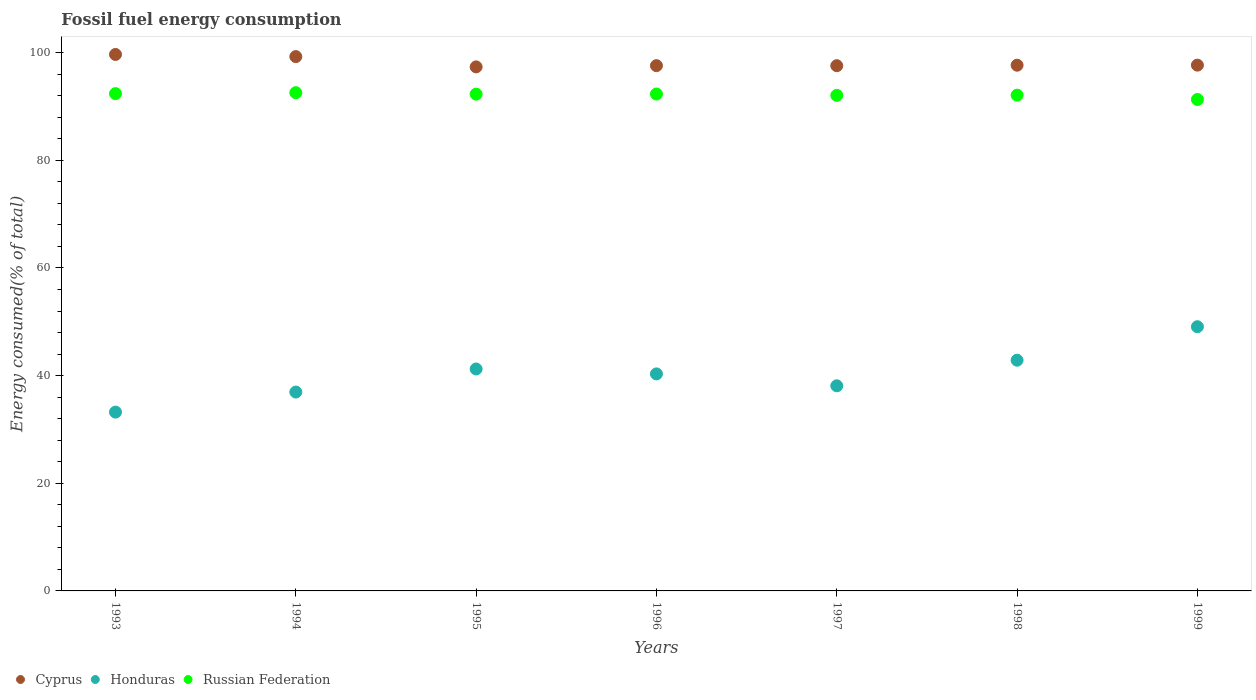Is the number of dotlines equal to the number of legend labels?
Offer a very short reply. Yes. What is the percentage of energy consumed in Honduras in 1994?
Give a very brief answer. 36.95. Across all years, what is the maximum percentage of energy consumed in Honduras?
Provide a short and direct response. 49.09. Across all years, what is the minimum percentage of energy consumed in Russian Federation?
Your answer should be compact. 91.31. In which year was the percentage of energy consumed in Russian Federation minimum?
Keep it short and to the point. 1999. What is the total percentage of energy consumed in Cyprus in the graph?
Offer a terse response. 686.87. What is the difference between the percentage of energy consumed in Cyprus in 1995 and that in 1998?
Provide a short and direct response. -0.31. What is the difference between the percentage of energy consumed in Cyprus in 1998 and the percentage of energy consumed in Honduras in 1996?
Your response must be concise. 57.35. What is the average percentage of energy consumed in Honduras per year?
Your response must be concise. 40.26. In the year 1993, what is the difference between the percentage of energy consumed in Honduras and percentage of energy consumed in Russian Federation?
Give a very brief answer. -59.17. What is the ratio of the percentage of energy consumed in Cyprus in 1994 to that in 1997?
Give a very brief answer. 1.02. Is the percentage of energy consumed in Honduras in 1996 less than that in 1998?
Your answer should be very brief. Yes. Is the difference between the percentage of energy consumed in Honduras in 1995 and 1997 greater than the difference between the percentage of energy consumed in Russian Federation in 1995 and 1997?
Offer a very short reply. Yes. What is the difference between the highest and the second highest percentage of energy consumed in Honduras?
Give a very brief answer. 6.22. What is the difference between the highest and the lowest percentage of energy consumed in Honduras?
Offer a very short reply. 15.87. Is the sum of the percentage of energy consumed in Cyprus in 1993 and 1995 greater than the maximum percentage of energy consumed in Russian Federation across all years?
Make the answer very short. Yes. Is it the case that in every year, the sum of the percentage of energy consumed in Cyprus and percentage of energy consumed in Honduras  is greater than the percentage of energy consumed in Russian Federation?
Your answer should be compact. Yes. Does the percentage of energy consumed in Cyprus monotonically increase over the years?
Make the answer very short. No. Is the percentage of energy consumed in Russian Federation strictly greater than the percentage of energy consumed in Honduras over the years?
Offer a very short reply. Yes. How many years are there in the graph?
Give a very brief answer. 7. What is the difference between two consecutive major ticks on the Y-axis?
Offer a terse response. 20. Does the graph contain grids?
Provide a short and direct response. No. Where does the legend appear in the graph?
Make the answer very short. Bottom left. How many legend labels are there?
Provide a succinct answer. 3. How are the legend labels stacked?
Your response must be concise. Horizontal. What is the title of the graph?
Make the answer very short. Fossil fuel energy consumption. What is the label or title of the X-axis?
Provide a succinct answer. Years. What is the label or title of the Y-axis?
Your answer should be very brief. Energy consumed(% of total). What is the Energy consumed(% of total) of Cyprus in 1993?
Give a very brief answer. 99.68. What is the Energy consumed(% of total) of Honduras in 1993?
Provide a short and direct response. 33.22. What is the Energy consumed(% of total) of Russian Federation in 1993?
Offer a terse response. 92.4. What is the Energy consumed(% of total) in Cyprus in 1994?
Provide a succinct answer. 99.28. What is the Energy consumed(% of total) in Honduras in 1994?
Your answer should be compact. 36.95. What is the Energy consumed(% of total) of Russian Federation in 1994?
Provide a succinct answer. 92.57. What is the Energy consumed(% of total) of Cyprus in 1995?
Keep it short and to the point. 97.37. What is the Energy consumed(% of total) in Honduras in 1995?
Make the answer very short. 41.24. What is the Energy consumed(% of total) in Russian Federation in 1995?
Keep it short and to the point. 92.3. What is the Energy consumed(% of total) in Cyprus in 1996?
Offer a very short reply. 97.59. What is the Energy consumed(% of total) of Honduras in 1996?
Provide a succinct answer. 40.32. What is the Energy consumed(% of total) of Russian Federation in 1996?
Make the answer very short. 92.32. What is the Energy consumed(% of total) of Cyprus in 1997?
Your answer should be compact. 97.59. What is the Energy consumed(% of total) in Honduras in 1997?
Offer a very short reply. 38.11. What is the Energy consumed(% of total) of Russian Federation in 1997?
Offer a very short reply. 92.07. What is the Energy consumed(% of total) of Cyprus in 1998?
Give a very brief answer. 97.68. What is the Energy consumed(% of total) in Honduras in 1998?
Offer a very short reply. 42.87. What is the Energy consumed(% of total) in Russian Federation in 1998?
Ensure brevity in your answer.  92.12. What is the Energy consumed(% of total) in Cyprus in 1999?
Provide a succinct answer. 97.69. What is the Energy consumed(% of total) in Honduras in 1999?
Your answer should be compact. 49.09. What is the Energy consumed(% of total) in Russian Federation in 1999?
Your answer should be compact. 91.31. Across all years, what is the maximum Energy consumed(% of total) of Cyprus?
Provide a succinct answer. 99.68. Across all years, what is the maximum Energy consumed(% of total) in Honduras?
Offer a terse response. 49.09. Across all years, what is the maximum Energy consumed(% of total) in Russian Federation?
Provide a succinct answer. 92.57. Across all years, what is the minimum Energy consumed(% of total) in Cyprus?
Make the answer very short. 97.37. Across all years, what is the minimum Energy consumed(% of total) in Honduras?
Provide a succinct answer. 33.22. Across all years, what is the minimum Energy consumed(% of total) in Russian Federation?
Your response must be concise. 91.31. What is the total Energy consumed(% of total) of Cyprus in the graph?
Give a very brief answer. 686.87. What is the total Energy consumed(% of total) of Honduras in the graph?
Give a very brief answer. 281.8. What is the total Energy consumed(% of total) of Russian Federation in the graph?
Your response must be concise. 645.09. What is the difference between the Energy consumed(% of total) of Cyprus in 1993 and that in 1994?
Your answer should be compact. 0.4. What is the difference between the Energy consumed(% of total) in Honduras in 1993 and that in 1994?
Provide a short and direct response. -3.73. What is the difference between the Energy consumed(% of total) of Russian Federation in 1993 and that in 1994?
Your response must be concise. -0.18. What is the difference between the Energy consumed(% of total) in Cyprus in 1993 and that in 1995?
Make the answer very short. 2.31. What is the difference between the Energy consumed(% of total) in Honduras in 1993 and that in 1995?
Offer a terse response. -8.01. What is the difference between the Energy consumed(% of total) in Russian Federation in 1993 and that in 1995?
Keep it short and to the point. 0.09. What is the difference between the Energy consumed(% of total) in Cyprus in 1993 and that in 1996?
Provide a succinct answer. 2.08. What is the difference between the Energy consumed(% of total) of Honduras in 1993 and that in 1996?
Keep it short and to the point. -7.1. What is the difference between the Energy consumed(% of total) of Russian Federation in 1993 and that in 1996?
Ensure brevity in your answer.  0.07. What is the difference between the Energy consumed(% of total) in Cyprus in 1993 and that in 1997?
Your response must be concise. 2.09. What is the difference between the Energy consumed(% of total) in Honduras in 1993 and that in 1997?
Keep it short and to the point. -4.89. What is the difference between the Energy consumed(% of total) in Russian Federation in 1993 and that in 1997?
Your answer should be very brief. 0.32. What is the difference between the Energy consumed(% of total) of Cyprus in 1993 and that in 1998?
Give a very brief answer. 2. What is the difference between the Energy consumed(% of total) in Honduras in 1993 and that in 1998?
Your answer should be very brief. -9.64. What is the difference between the Energy consumed(% of total) of Russian Federation in 1993 and that in 1998?
Give a very brief answer. 0.28. What is the difference between the Energy consumed(% of total) in Cyprus in 1993 and that in 1999?
Provide a succinct answer. 1.98. What is the difference between the Energy consumed(% of total) in Honduras in 1993 and that in 1999?
Make the answer very short. -15.87. What is the difference between the Energy consumed(% of total) in Russian Federation in 1993 and that in 1999?
Keep it short and to the point. 1.09. What is the difference between the Energy consumed(% of total) of Cyprus in 1994 and that in 1995?
Offer a very short reply. 1.91. What is the difference between the Energy consumed(% of total) in Honduras in 1994 and that in 1995?
Give a very brief answer. -4.28. What is the difference between the Energy consumed(% of total) of Russian Federation in 1994 and that in 1995?
Give a very brief answer. 0.27. What is the difference between the Energy consumed(% of total) in Cyprus in 1994 and that in 1996?
Your answer should be compact. 1.68. What is the difference between the Energy consumed(% of total) in Honduras in 1994 and that in 1996?
Your response must be concise. -3.37. What is the difference between the Energy consumed(% of total) of Russian Federation in 1994 and that in 1996?
Provide a succinct answer. 0.25. What is the difference between the Energy consumed(% of total) in Cyprus in 1994 and that in 1997?
Ensure brevity in your answer.  1.69. What is the difference between the Energy consumed(% of total) in Honduras in 1994 and that in 1997?
Make the answer very short. -1.16. What is the difference between the Energy consumed(% of total) of Russian Federation in 1994 and that in 1997?
Make the answer very short. 0.5. What is the difference between the Energy consumed(% of total) in Cyprus in 1994 and that in 1998?
Provide a succinct answer. 1.6. What is the difference between the Energy consumed(% of total) of Honduras in 1994 and that in 1998?
Your answer should be compact. -5.92. What is the difference between the Energy consumed(% of total) in Russian Federation in 1994 and that in 1998?
Keep it short and to the point. 0.46. What is the difference between the Energy consumed(% of total) in Cyprus in 1994 and that in 1999?
Ensure brevity in your answer.  1.59. What is the difference between the Energy consumed(% of total) of Honduras in 1994 and that in 1999?
Offer a terse response. -12.14. What is the difference between the Energy consumed(% of total) of Russian Federation in 1994 and that in 1999?
Keep it short and to the point. 1.26. What is the difference between the Energy consumed(% of total) of Cyprus in 1995 and that in 1996?
Your answer should be compact. -0.23. What is the difference between the Energy consumed(% of total) of Honduras in 1995 and that in 1996?
Your response must be concise. 0.91. What is the difference between the Energy consumed(% of total) of Russian Federation in 1995 and that in 1996?
Your response must be concise. -0.02. What is the difference between the Energy consumed(% of total) in Cyprus in 1995 and that in 1997?
Give a very brief answer. -0.22. What is the difference between the Energy consumed(% of total) in Honduras in 1995 and that in 1997?
Provide a succinct answer. 3.13. What is the difference between the Energy consumed(% of total) in Russian Federation in 1995 and that in 1997?
Make the answer very short. 0.23. What is the difference between the Energy consumed(% of total) in Cyprus in 1995 and that in 1998?
Offer a terse response. -0.31. What is the difference between the Energy consumed(% of total) of Honduras in 1995 and that in 1998?
Your answer should be compact. -1.63. What is the difference between the Energy consumed(% of total) in Russian Federation in 1995 and that in 1998?
Provide a succinct answer. 0.19. What is the difference between the Energy consumed(% of total) of Cyprus in 1995 and that in 1999?
Offer a very short reply. -0.33. What is the difference between the Energy consumed(% of total) in Honduras in 1995 and that in 1999?
Keep it short and to the point. -7.85. What is the difference between the Energy consumed(% of total) of Cyprus in 1996 and that in 1997?
Ensure brevity in your answer.  0.01. What is the difference between the Energy consumed(% of total) in Honduras in 1996 and that in 1997?
Make the answer very short. 2.21. What is the difference between the Energy consumed(% of total) of Russian Federation in 1996 and that in 1997?
Your answer should be very brief. 0.25. What is the difference between the Energy consumed(% of total) in Cyprus in 1996 and that in 1998?
Give a very brief answer. -0.08. What is the difference between the Energy consumed(% of total) of Honduras in 1996 and that in 1998?
Your answer should be compact. -2.55. What is the difference between the Energy consumed(% of total) of Russian Federation in 1996 and that in 1998?
Your answer should be compact. 0.21. What is the difference between the Energy consumed(% of total) of Cyprus in 1996 and that in 1999?
Keep it short and to the point. -0.1. What is the difference between the Energy consumed(% of total) of Honduras in 1996 and that in 1999?
Your response must be concise. -8.77. What is the difference between the Energy consumed(% of total) in Russian Federation in 1996 and that in 1999?
Offer a terse response. 1.01. What is the difference between the Energy consumed(% of total) of Cyprus in 1997 and that in 1998?
Your answer should be compact. -0.09. What is the difference between the Energy consumed(% of total) in Honduras in 1997 and that in 1998?
Keep it short and to the point. -4.76. What is the difference between the Energy consumed(% of total) of Russian Federation in 1997 and that in 1998?
Your answer should be very brief. -0.04. What is the difference between the Energy consumed(% of total) in Cyprus in 1997 and that in 1999?
Give a very brief answer. -0.11. What is the difference between the Energy consumed(% of total) of Honduras in 1997 and that in 1999?
Your response must be concise. -10.98. What is the difference between the Energy consumed(% of total) of Russian Federation in 1997 and that in 1999?
Give a very brief answer. 0.76. What is the difference between the Energy consumed(% of total) in Cyprus in 1998 and that in 1999?
Keep it short and to the point. -0.01. What is the difference between the Energy consumed(% of total) of Honduras in 1998 and that in 1999?
Ensure brevity in your answer.  -6.22. What is the difference between the Energy consumed(% of total) in Russian Federation in 1998 and that in 1999?
Make the answer very short. 0.81. What is the difference between the Energy consumed(% of total) in Cyprus in 1993 and the Energy consumed(% of total) in Honduras in 1994?
Make the answer very short. 62.72. What is the difference between the Energy consumed(% of total) in Cyprus in 1993 and the Energy consumed(% of total) in Russian Federation in 1994?
Make the answer very short. 7.1. What is the difference between the Energy consumed(% of total) in Honduras in 1993 and the Energy consumed(% of total) in Russian Federation in 1994?
Make the answer very short. -59.35. What is the difference between the Energy consumed(% of total) in Cyprus in 1993 and the Energy consumed(% of total) in Honduras in 1995?
Provide a short and direct response. 58.44. What is the difference between the Energy consumed(% of total) of Cyprus in 1993 and the Energy consumed(% of total) of Russian Federation in 1995?
Your answer should be compact. 7.37. What is the difference between the Energy consumed(% of total) of Honduras in 1993 and the Energy consumed(% of total) of Russian Federation in 1995?
Your answer should be very brief. -59.08. What is the difference between the Energy consumed(% of total) of Cyprus in 1993 and the Energy consumed(% of total) of Honduras in 1996?
Offer a terse response. 59.35. What is the difference between the Energy consumed(% of total) in Cyprus in 1993 and the Energy consumed(% of total) in Russian Federation in 1996?
Make the answer very short. 7.35. What is the difference between the Energy consumed(% of total) in Honduras in 1993 and the Energy consumed(% of total) in Russian Federation in 1996?
Your response must be concise. -59.1. What is the difference between the Energy consumed(% of total) of Cyprus in 1993 and the Energy consumed(% of total) of Honduras in 1997?
Provide a short and direct response. 61.57. What is the difference between the Energy consumed(% of total) of Cyprus in 1993 and the Energy consumed(% of total) of Russian Federation in 1997?
Offer a very short reply. 7.6. What is the difference between the Energy consumed(% of total) of Honduras in 1993 and the Energy consumed(% of total) of Russian Federation in 1997?
Give a very brief answer. -58.85. What is the difference between the Energy consumed(% of total) of Cyprus in 1993 and the Energy consumed(% of total) of Honduras in 1998?
Keep it short and to the point. 56.81. What is the difference between the Energy consumed(% of total) of Cyprus in 1993 and the Energy consumed(% of total) of Russian Federation in 1998?
Your answer should be compact. 7.56. What is the difference between the Energy consumed(% of total) in Honduras in 1993 and the Energy consumed(% of total) in Russian Federation in 1998?
Ensure brevity in your answer.  -58.89. What is the difference between the Energy consumed(% of total) in Cyprus in 1993 and the Energy consumed(% of total) in Honduras in 1999?
Give a very brief answer. 50.59. What is the difference between the Energy consumed(% of total) in Cyprus in 1993 and the Energy consumed(% of total) in Russian Federation in 1999?
Your answer should be very brief. 8.37. What is the difference between the Energy consumed(% of total) in Honduras in 1993 and the Energy consumed(% of total) in Russian Federation in 1999?
Keep it short and to the point. -58.09. What is the difference between the Energy consumed(% of total) of Cyprus in 1994 and the Energy consumed(% of total) of Honduras in 1995?
Provide a succinct answer. 58.04. What is the difference between the Energy consumed(% of total) of Cyprus in 1994 and the Energy consumed(% of total) of Russian Federation in 1995?
Provide a short and direct response. 6.98. What is the difference between the Energy consumed(% of total) of Honduras in 1994 and the Energy consumed(% of total) of Russian Federation in 1995?
Provide a succinct answer. -55.35. What is the difference between the Energy consumed(% of total) of Cyprus in 1994 and the Energy consumed(% of total) of Honduras in 1996?
Offer a terse response. 58.95. What is the difference between the Energy consumed(% of total) of Cyprus in 1994 and the Energy consumed(% of total) of Russian Federation in 1996?
Your response must be concise. 6.95. What is the difference between the Energy consumed(% of total) in Honduras in 1994 and the Energy consumed(% of total) in Russian Federation in 1996?
Ensure brevity in your answer.  -55.37. What is the difference between the Energy consumed(% of total) in Cyprus in 1994 and the Energy consumed(% of total) in Honduras in 1997?
Provide a succinct answer. 61.17. What is the difference between the Energy consumed(% of total) in Cyprus in 1994 and the Energy consumed(% of total) in Russian Federation in 1997?
Make the answer very short. 7.21. What is the difference between the Energy consumed(% of total) of Honduras in 1994 and the Energy consumed(% of total) of Russian Federation in 1997?
Offer a terse response. -55.12. What is the difference between the Energy consumed(% of total) of Cyprus in 1994 and the Energy consumed(% of total) of Honduras in 1998?
Your answer should be compact. 56.41. What is the difference between the Energy consumed(% of total) in Cyprus in 1994 and the Energy consumed(% of total) in Russian Federation in 1998?
Make the answer very short. 7.16. What is the difference between the Energy consumed(% of total) in Honduras in 1994 and the Energy consumed(% of total) in Russian Federation in 1998?
Provide a succinct answer. -55.16. What is the difference between the Energy consumed(% of total) in Cyprus in 1994 and the Energy consumed(% of total) in Honduras in 1999?
Your response must be concise. 50.19. What is the difference between the Energy consumed(% of total) of Cyprus in 1994 and the Energy consumed(% of total) of Russian Federation in 1999?
Your response must be concise. 7.97. What is the difference between the Energy consumed(% of total) in Honduras in 1994 and the Energy consumed(% of total) in Russian Federation in 1999?
Provide a short and direct response. -54.36. What is the difference between the Energy consumed(% of total) of Cyprus in 1995 and the Energy consumed(% of total) of Honduras in 1996?
Your answer should be compact. 57.04. What is the difference between the Energy consumed(% of total) of Cyprus in 1995 and the Energy consumed(% of total) of Russian Federation in 1996?
Make the answer very short. 5.04. What is the difference between the Energy consumed(% of total) of Honduras in 1995 and the Energy consumed(% of total) of Russian Federation in 1996?
Make the answer very short. -51.09. What is the difference between the Energy consumed(% of total) in Cyprus in 1995 and the Energy consumed(% of total) in Honduras in 1997?
Provide a short and direct response. 59.26. What is the difference between the Energy consumed(% of total) of Cyprus in 1995 and the Energy consumed(% of total) of Russian Federation in 1997?
Your answer should be compact. 5.29. What is the difference between the Energy consumed(% of total) of Honduras in 1995 and the Energy consumed(% of total) of Russian Federation in 1997?
Your answer should be compact. -50.84. What is the difference between the Energy consumed(% of total) of Cyprus in 1995 and the Energy consumed(% of total) of Honduras in 1998?
Offer a very short reply. 54.5. What is the difference between the Energy consumed(% of total) of Cyprus in 1995 and the Energy consumed(% of total) of Russian Federation in 1998?
Provide a succinct answer. 5.25. What is the difference between the Energy consumed(% of total) of Honduras in 1995 and the Energy consumed(% of total) of Russian Federation in 1998?
Provide a short and direct response. -50.88. What is the difference between the Energy consumed(% of total) of Cyprus in 1995 and the Energy consumed(% of total) of Honduras in 1999?
Your answer should be very brief. 48.28. What is the difference between the Energy consumed(% of total) in Cyprus in 1995 and the Energy consumed(% of total) in Russian Federation in 1999?
Keep it short and to the point. 6.06. What is the difference between the Energy consumed(% of total) of Honduras in 1995 and the Energy consumed(% of total) of Russian Federation in 1999?
Keep it short and to the point. -50.07. What is the difference between the Energy consumed(% of total) in Cyprus in 1996 and the Energy consumed(% of total) in Honduras in 1997?
Your answer should be compact. 59.48. What is the difference between the Energy consumed(% of total) of Cyprus in 1996 and the Energy consumed(% of total) of Russian Federation in 1997?
Your answer should be very brief. 5.52. What is the difference between the Energy consumed(% of total) in Honduras in 1996 and the Energy consumed(% of total) in Russian Federation in 1997?
Provide a short and direct response. -51.75. What is the difference between the Energy consumed(% of total) of Cyprus in 1996 and the Energy consumed(% of total) of Honduras in 1998?
Provide a succinct answer. 54.72. What is the difference between the Energy consumed(% of total) in Cyprus in 1996 and the Energy consumed(% of total) in Russian Federation in 1998?
Make the answer very short. 5.48. What is the difference between the Energy consumed(% of total) in Honduras in 1996 and the Energy consumed(% of total) in Russian Federation in 1998?
Offer a terse response. -51.79. What is the difference between the Energy consumed(% of total) in Cyprus in 1996 and the Energy consumed(% of total) in Honduras in 1999?
Your answer should be compact. 48.5. What is the difference between the Energy consumed(% of total) in Cyprus in 1996 and the Energy consumed(% of total) in Russian Federation in 1999?
Your answer should be very brief. 6.28. What is the difference between the Energy consumed(% of total) in Honduras in 1996 and the Energy consumed(% of total) in Russian Federation in 1999?
Give a very brief answer. -50.99. What is the difference between the Energy consumed(% of total) of Cyprus in 1997 and the Energy consumed(% of total) of Honduras in 1998?
Your answer should be very brief. 54.72. What is the difference between the Energy consumed(% of total) of Cyprus in 1997 and the Energy consumed(% of total) of Russian Federation in 1998?
Give a very brief answer. 5.47. What is the difference between the Energy consumed(% of total) in Honduras in 1997 and the Energy consumed(% of total) in Russian Federation in 1998?
Make the answer very short. -54.01. What is the difference between the Energy consumed(% of total) in Cyprus in 1997 and the Energy consumed(% of total) in Honduras in 1999?
Offer a very short reply. 48.5. What is the difference between the Energy consumed(% of total) of Cyprus in 1997 and the Energy consumed(% of total) of Russian Federation in 1999?
Offer a very short reply. 6.28. What is the difference between the Energy consumed(% of total) of Honduras in 1997 and the Energy consumed(% of total) of Russian Federation in 1999?
Offer a very short reply. -53.2. What is the difference between the Energy consumed(% of total) in Cyprus in 1998 and the Energy consumed(% of total) in Honduras in 1999?
Give a very brief answer. 48.59. What is the difference between the Energy consumed(% of total) of Cyprus in 1998 and the Energy consumed(% of total) of Russian Federation in 1999?
Ensure brevity in your answer.  6.37. What is the difference between the Energy consumed(% of total) in Honduras in 1998 and the Energy consumed(% of total) in Russian Federation in 1999?
Your response must be concise. -48.44. What is the average Energy consumed(% of total) in Cyprus per year?
Ensure brevity in your answer.  98.12. What is the average Energy consumed(% of total) of Honduras per year?
Keep it short and to the point. 40.26. What is the average Energy consumed(% of total) in Russian Federation per year?
Your answer should be very brief. 92.16. In the year 1993, what is the difference between the Energy consumed(% of total) of Cyprus and Energy consumed(% of total) of Honduras?
Your response must be concise. 66.45. In the year 1993, what is the difference between the Energy consumed(% of total) in Cyprus and Energy consumed(% of total) in Russian Federation?
Your answer should be compact. 7.28. In the year 1993, what is the difference between the Energy consumed(% of total) in Honduras and Energy consumed(% of total) in Russian Federation?
Your response must be concise. -59.17. In the year 1994, what is the difference between the Energy consumed(% of total) of Cyprus and Energy consumed(% of total) of Honduras?
Make the answer very short. 62.33. In the year 1994, what is the difference between the Energy consumed(% of total) in Cyprus and Energy consumed(% of total) in Russian Federation?
Provide a succinct answer. 6.7. In the year 1994, what is the difference between the Energy consumed(% of total) in Honduras and Energy consumed(% of total) in Russian Federation?
Offer a terse response. -55.62. In the year 1995, what is the difference between the Energy consumed(% of total) in Cyprus and Energy consumed(% of total) in Honduras?
Keep it short and to the point. 56.13. In the year 1995, what is the difference between the Energy consumed(% of total) in Cyprus and Energy consumed(% of total) in Russian Federation?
Your answer should be compact. 5.06. In the year 1995, what is the difference between the Energy consumed(% of total) of Honduras and Energy consumed(% of total) of Russian Federation?
Give a very brief answer. -51.06. In the year 1996, what is the difference between the Energy consumed(% of total) in Cyprus and Energy consumed(% of total) in Honduras?
Provide a succinct answer. 57.27. In the year 1996, what is the difference between the Energy consumed(% of total) of Cyprus and Energy consumed(% of total) of Russian Federation?
Offer a very short reply. 5.27. In the year 1996, what is the difference between the Energy consumed(% of total) of Honduras and Energy consumed(% of total) of Russian Federation?
Offer a terse response. -52. In the year 1997, what is the difference between the Energy consumed(% of total) of Cyprus and Energy consumed(% of total) of Honduras?
Your answer should be compact. 59.48. In the year 1997, what is the difference between the Energy consumed(% of total) of Cyprus and Energy consumed(% of total) of Russian Federation?
Your response must be concise. 5.51. In the year 1997, what is the difference between the Energy consumed(% of total) in Honduras and Energy consumed(% of total) in Russian Federation?
Give a very brief answer. -53.96. In the year 1998, what is the difference between the Energy consumed(% of total) in Cyprus and Energy consumed(% of total) in Honduras?
Your answer should be very brief. 54.81. In the year 1998, what is the difference between the Energy consumed(% of total) of Cyprus and Energy consumed(% of total) of Russian Federation?
Your answer should be very brief. 5.56. In the year 1998, what is the difference between the Energy consumed(% of total) in Honduras and Energy consumed(% of total) in Russian Federation?
Your response must be concise. -49.25. In the year 1999, what is the difference between the Energy consumed(% of total) in Cyprus and Energy consumed(% of total) in Honduras?
Make the answer very short. 48.6. In the year 1999, what is the difference between the Energy consumed(% of total) of Cyprus and Energy consumed(% of total) of Russian Federation?
Make the answer very short. 6.38. In the year 1999, what is the difference between the Energy consumed(% of total) in Honduras and Energy consumed(% of total) in Russian Federation?
Ensure brevity in your answer.  -42.22. What is the ratio of the Energy consumed(% of total) of Honduras in 1993 to that in 1994?
Your answer should be compact. 0.9. What is the ratio of the Energy consumed(% of total) in Russian Federation in 1993 to that in 1994?
Give a very brief answer. 1. What is the ratio of the Energy consumed(% of total) of Cyprus in 1993 to that in 1995?
Offer a very short reply. 1.02. What is the ratio of the Energy consumed(% of total) in Honduras in 1993 to that in 1995?
Provide a succinct answer. 0.81. What is the ratio of the Energy consumed(% of total) in Russian Federation in 1993 to that in 1995?
Your answer should be very brief. 1. What is the ratio of the Energy consumed(% of total) in Cyprus in 1993 to that in 1996?
Your answer should be compact. 1.02. What is the ratio of the Energy consumed(% of total) in Honduras in 1993 to that in 1996?
Give a very brief answer. 0.82. What is the ratio of the Energy consumed(% of total) in Russian Federation in 1993 to that in 1996?
Keep it short and to the point. 1. What is the ratio of the Energy consumed(% of total) of Cyprus in 1993 to that in 1997?
Your response must be concise. 1.02. What is the ratio of the Energy consumed(% of total) of Honduras in 1993 to that in 1997?
Your answer should be compact. 0.87. What is the ratio of the Energy consumed(% of total) in Russian Federation in 1993 to that in 1997?
Give a very brief answer. 1. What is the ratio of the Energy consumed(% of total) of Cyprus in 1993 to that in 1998?
Offer a very short reply. 1.02. What is the ratio of the Energy consumed(% of total) of Honduras in 1993 to that in 1998?
Your answer should be compact. 0.78. What is the ratio of the Energy consumed(% of total) in Cyprus in 1993 to that in 1999?
Offer a very short reply. 1.02. What is the ratio of the Energy consumed(% of total) of Honduras in 1993 to that in 1999?
Provide a succinct answer. 0.68. What is the ratio of the Energy consumed(% of total) in Russian Federation in 1993 to that in 1999?
Provide a succinct answer. 1.01. What is the ratio of the Energy consumed(% of total) in Cyprus in 1994 to that in 1995?
Give a very brief answer. 1.02. What is the ratio of the Energy consumed(% of total) of Honduras in 1994 to that in 1995?
Ensure brevity in your answer.  0.9. What is the ratio of the Energy consumed(% of total) of Russian Federation in 1994 to that in 1995?
Provide a short and direct response. 1. What is the ratio of the Energy consumed(% of total) of Cyprus in 1994 to that in 1996?
Make the answer very short. 1.02. What is the ratio of the Energy consumed(% of total) of Honduras in 1994 to that in 1996?
Offer a very short reply. 0.92. What is the ratio of the Energy consumed(% of total) of Russian Federation in 1994 to that in 1996?
Provide a short and direct response. 1. What is the ratio of the Energy consumed(% of total) of Cyprus in 1994 to that in 1997?
Your response must be concise. 1.02. What is the ratio of the Energy consumed(% of total) of Honduras in 1994 to that in 1997?
Provide a short and direct response. 0.97. What is the ratio of the Energy consumed(% of total) in Russian Federation in 1994 to that in 1997?
Make the answer very short. 1.01. What is the ratio of the Energy consumed(% of total) of Cyprus in 1994 to that in 1998?
Your answer should be very brief. 1.02. What is the ratio of the Energy consumed(% of total) in Honduras in 1994 to that in 1998?
Offer a terse response. 0.86. What is the ratio of the Energy consumed(% of total) of Russian Federation in 1994 to that in 1998?
Offer a very short reply. 1. What is the ratio of the Energy consumed(% of total) of Cyprus in 1994 to that in 1999?
Provide a succinct answer. 1.02. What is the ratio of the Energy consumed(% of total) of Honduras in 1994 to that in 1999?
Provide a succinct answer. 0.75. What is the ratio of the Energy consumed(% of total) in Russian Federation in 1994 to that in 1999?
Offer a terse response. 1.01. What is the ratio of the Energy consumed(% of total) of Honduras in 1995 to that in 1996?
Keep it short and to the point. 1.02. What is the ratio of the Energy consumed(% of total) in Russian Federation in 1995 to that in 1996?
Ensure brevity in your answer.  1. What is the ratio of the Energy consumed(% of total) of Cyprus in 1995 to that in 1997?
Offer a terse response. 1. What is the ratio of the Energy consumed(% of total) in Honduras in 1995 to that in 1997?
Offer a very short reply. 1.08. What is the ratio of the Energy consumed(% of total) in Russian Federation in 1995 to that in 1997?
Provide a succinct answer. 1. What is the ratio of the Energy consumed(% of total) in Honduras in 1995 to that in 1998?
Make the answer very short. 0.96. What is the ratio of the Energy consumed(% of total) of Russian Federation in 1995 to that in 1998?
Keep it short and to the point. 1. What is the ratio of the Energy consumed(% of total) of Honduras in 1995 to that in 1999?
Ensure brevity in your answer.  0.84. What is the ratio of the Energy consumed(% of total) in Russian Federation in 1995 to that in 1999?
Offer a very short reply. 1.01. What is the ratio of the Energy consumed(% of total) of Honduras in 1996 to that in 1997?
Your answer should be compact. 1.06. What is the ratio of the Energy consumed(% of total) of Russian Federation in 1996 to that in 1997?
Your response must be concise. 1. What is the ratio of the Energy consumed(% of total) in Cyprus in 1996 to that in 1998?
Make the answer very short. 1. What is the ratio of the Energy consumed(% of total) of Honduras in 1996 to that in 1998?
Give a very brief answer. 0.94. What is the ratio of the Energy consumed(% of total) in Russian Federation in 1996 to that in 1998?
Your answer should be very brief. 1. What is the ratio of the Energy consumed(% of total) in Cyprus in 1996 to that in 1999?
Keep it short and to the point. 1. What is the ratio of the Energy consumed(% of total) of Honduras in 1996 to that in 1999?
Offer a terse response. 0.82. What is the ratio of the Energy consumed(% of total) in Russian Federation in 1996 to that in 1999?
Give a very brief answer. 1.01. What is the ratio of the Energy consumed(% of total) in Honduras in 1997 to that in 1998?
Give a very brief answer. 0.89. What is the ratio of the Energy consumed(% of total) in Cyprus in 1997 to that in 1999?
Ensure brevity in your answer.  1. What is the ratio of the Energy consumed(% of total) of Honduras in 1997 to that in 1999?
Your answer should be very brief. 0.78. What is the ratio of the Energy consumed(% of total) in Russian Federation in 1997 to that in 1999?
Offer a very short reply. 1.01. What is the ratio of the Energy consumed(% of total) of Honduras in 1998 to that in 1999?
Your response must be concise. 0.87. What is the ratio of the Energy consumed(% of total) of Russian Federation in 1998 to that in 1999?
Your answer should be compact. 1.01. What is the difference between the highest and the second highest Energy consumed(% of total) in Cyprus?
Provide a succinct answer. 0.4. What is the difference between the highest and the second highest Energy consumed(% of total) in Honduras?
Your answer should be very brief. 6.22. What is the difference between the highest and the second highest Energy consumed(% of total) in Russian Federation?
Offer a very short reply. 0.18. What is the difference between the highest and the lowest Energy consumed(% of total) in Cyprus?
Your answer should be very brief. 2.31. What is the difference between the highest and the lowest Energy consumed(% of total) in Honduras?
Your answer should be very brief. 15.87. What is the difference between the highest and the lowest Energy consumed(% of total) of Russian Federation?
Your answer should be very brief. 1.26. 